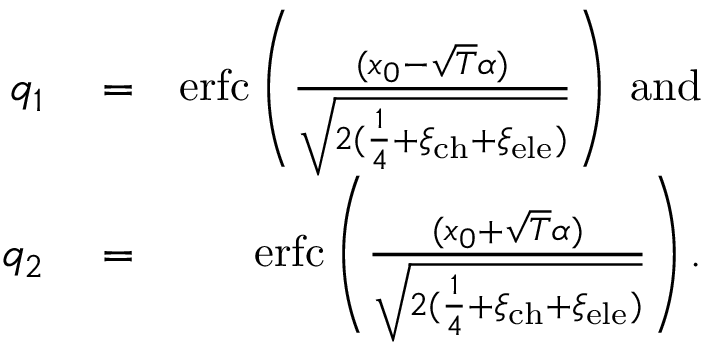Convert formula to latex. <formula><loc_0><loc_0><loc_500><loc_500>\begin{array} { r l r } { q _ { 1 } } & = } & { e r f c \left ( \frac { ( x _ { 0 } - \sqrt { T } \alpha ) } { \sqrt { 2 ( \frac { 1 } { 4 } + \xi _ { c h } + \xi _ { e l e } ) } } \right ) \ { a n d } } \\ { q _ { 2 } } & = } & { e r f c \left ( \frac { ( x _ { 0 } + \sqrt { T } \alpha ) } { \sqrt { 2 ( \frac { 1 } { 4 } + \xi _ { c h } + \xi _ { e l e } ) } } \right ) . } \end{array}</formula> 